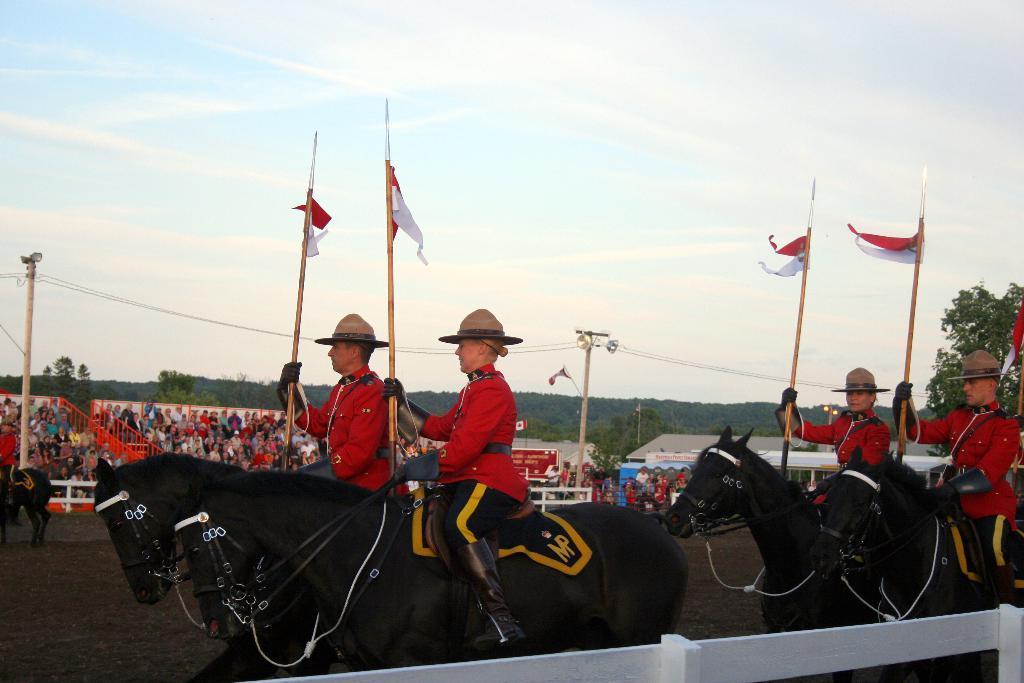How would you summarize this image in a sentence or two? In the center of the image we can see four persons are riding horses and they are in different costumes and they are holding flags. And we can see belts are attached to the horses. At the bottom of the image, there is a white color object. In the background, we can see the sky, clouds, trees, poles, one horse, fences, few people and a few other objects. 